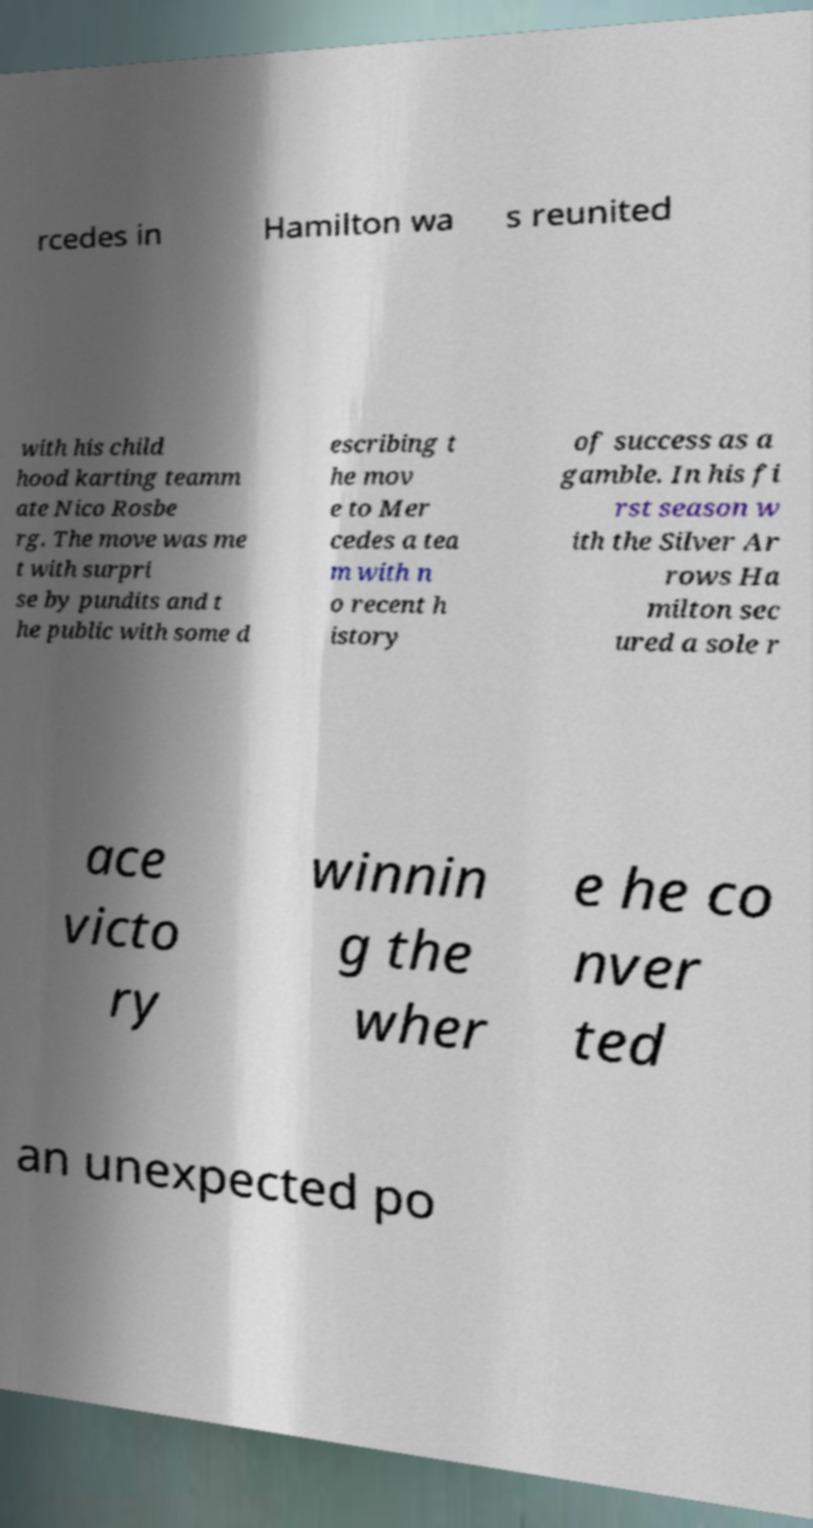Could you extract and type out the text from this image? rcedes in Hamilton wa s reunited with his child hood karting teamm ate Nico Rosbe rg. The move was me t with surpri se by pundits and t he public with some d escribing t he mov e to Mer cedes a tea m with n o recent h istory of success as a gamble. In his fi rst season w ith the Silver Ar rows Ha milton sec ured a sole r ace victo ry winnin g the wher e he co nver ted an unexpected po 